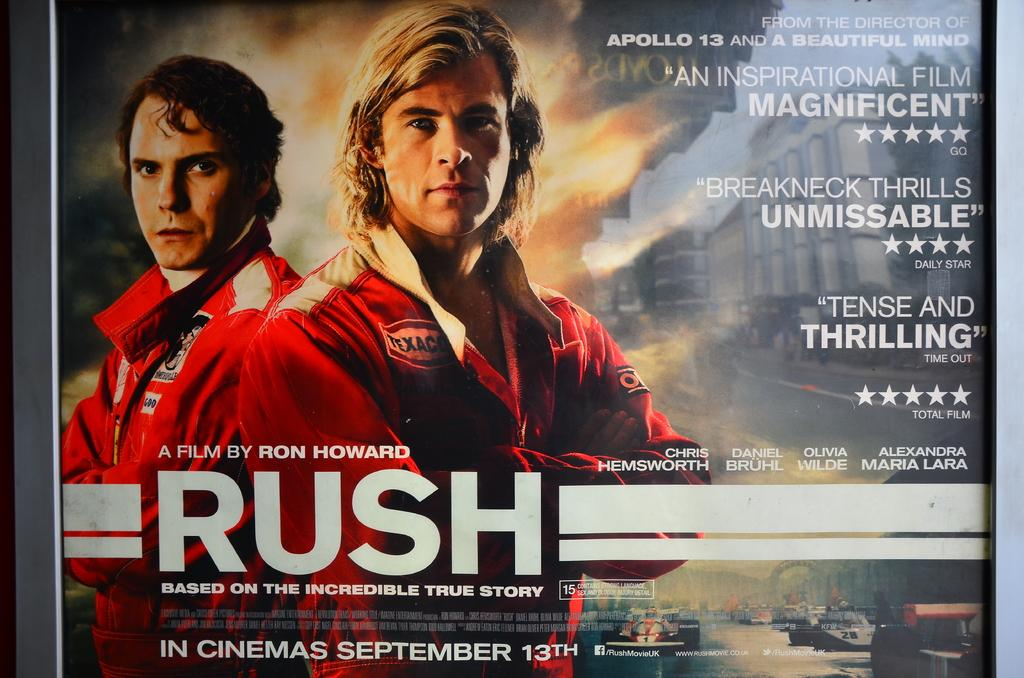Provide a one-sentence caption for the provided image. An advertisement for the movie Rush, a film by Ron Howard describes the move as "Tense and Thrilling". 